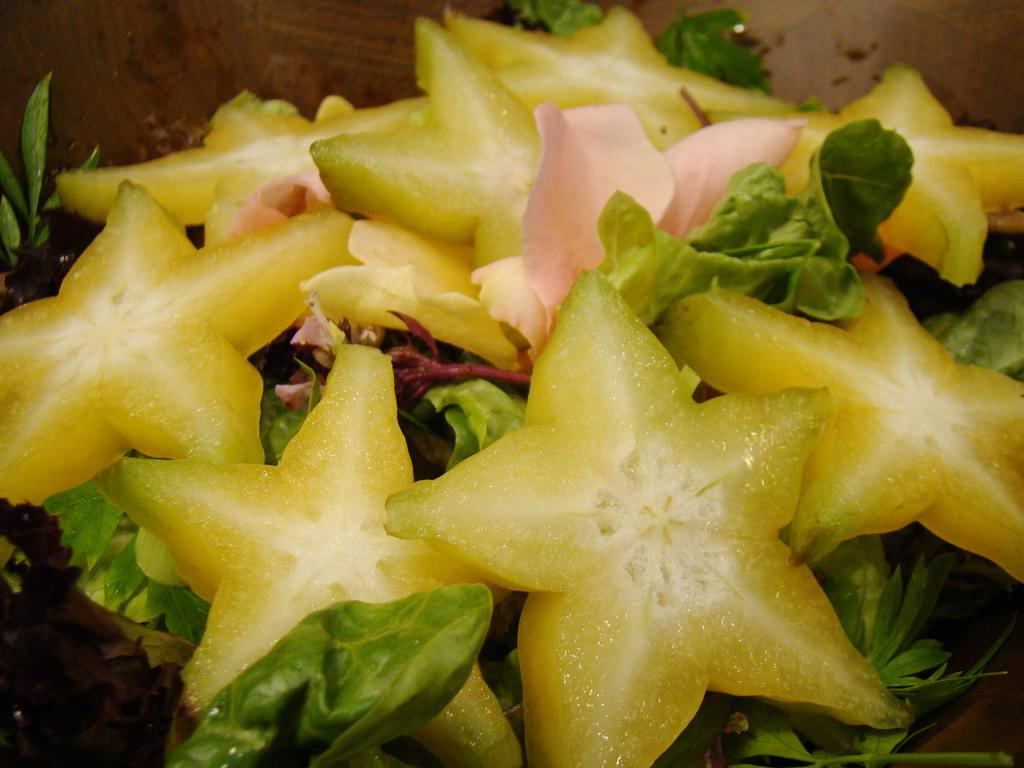What type of fruits are in the image? The image contains star fruits. What type of vegetables are in the image? The image contains leafy vegetables. What color is the background of the image? The background of the image is brown in color. What type of wheel can be seen in the image? There is no wheel present in the image. What color is the orange in the image? There is no orange present in the image. 